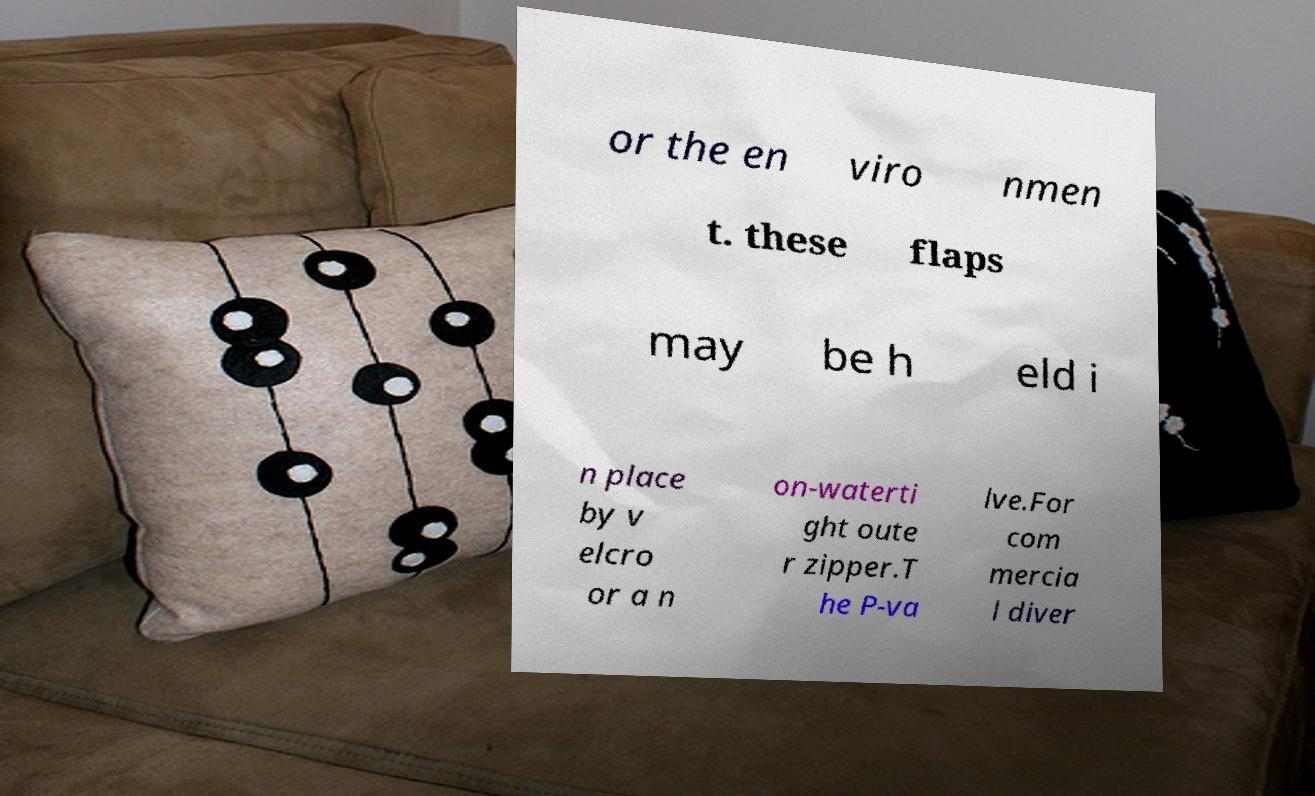Can you read and provide the text displayed in the image?This photo seems to have some interesting text. Can you extract and type it out for me? or the en viro nmen t. these flaps may be h eld i n place by v elcro or a n on-waterti ght oute r zipper.T he P-va lve.For com mercia l diver 